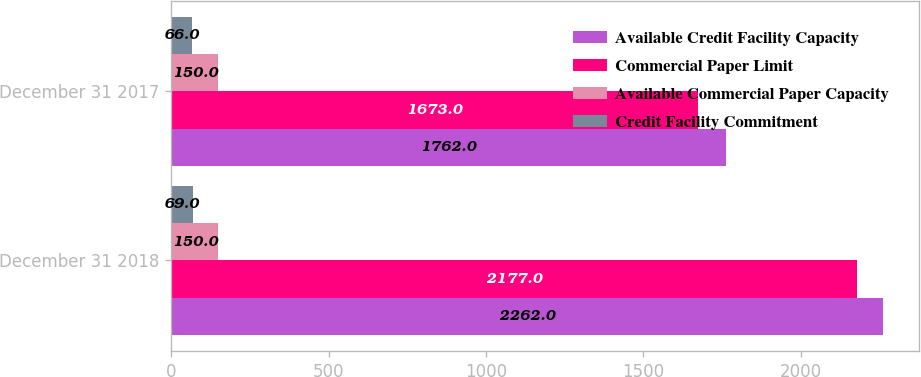Convert chart to OTSL. <chart><loc_0><loc_0><loc_500><loc_500><stacked_bar_chart><ecel><fcel>December 31 2018<fcel>December 31 2017<nl><fcel>Available Credit Facility Capacity<fcel>2262<fcel>1762<nl><fcel>Commercial Paper Limit<fcel>2177<fcel>1673<nl><fcel>Available Commercial Paper Capacity<fcel>150<fcel>150<nl><fcel>Credit Facility Commitment<fcel>69<fcel>66<nl></chart> 